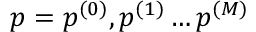Convert formula to latex. <formula><loc_0><loc_0><loc_500><loc_500>p = { p ^ { ( 0 ) } , p ^ { ( 1 ) } \dots p ^ { ( M ) } }</formula> 